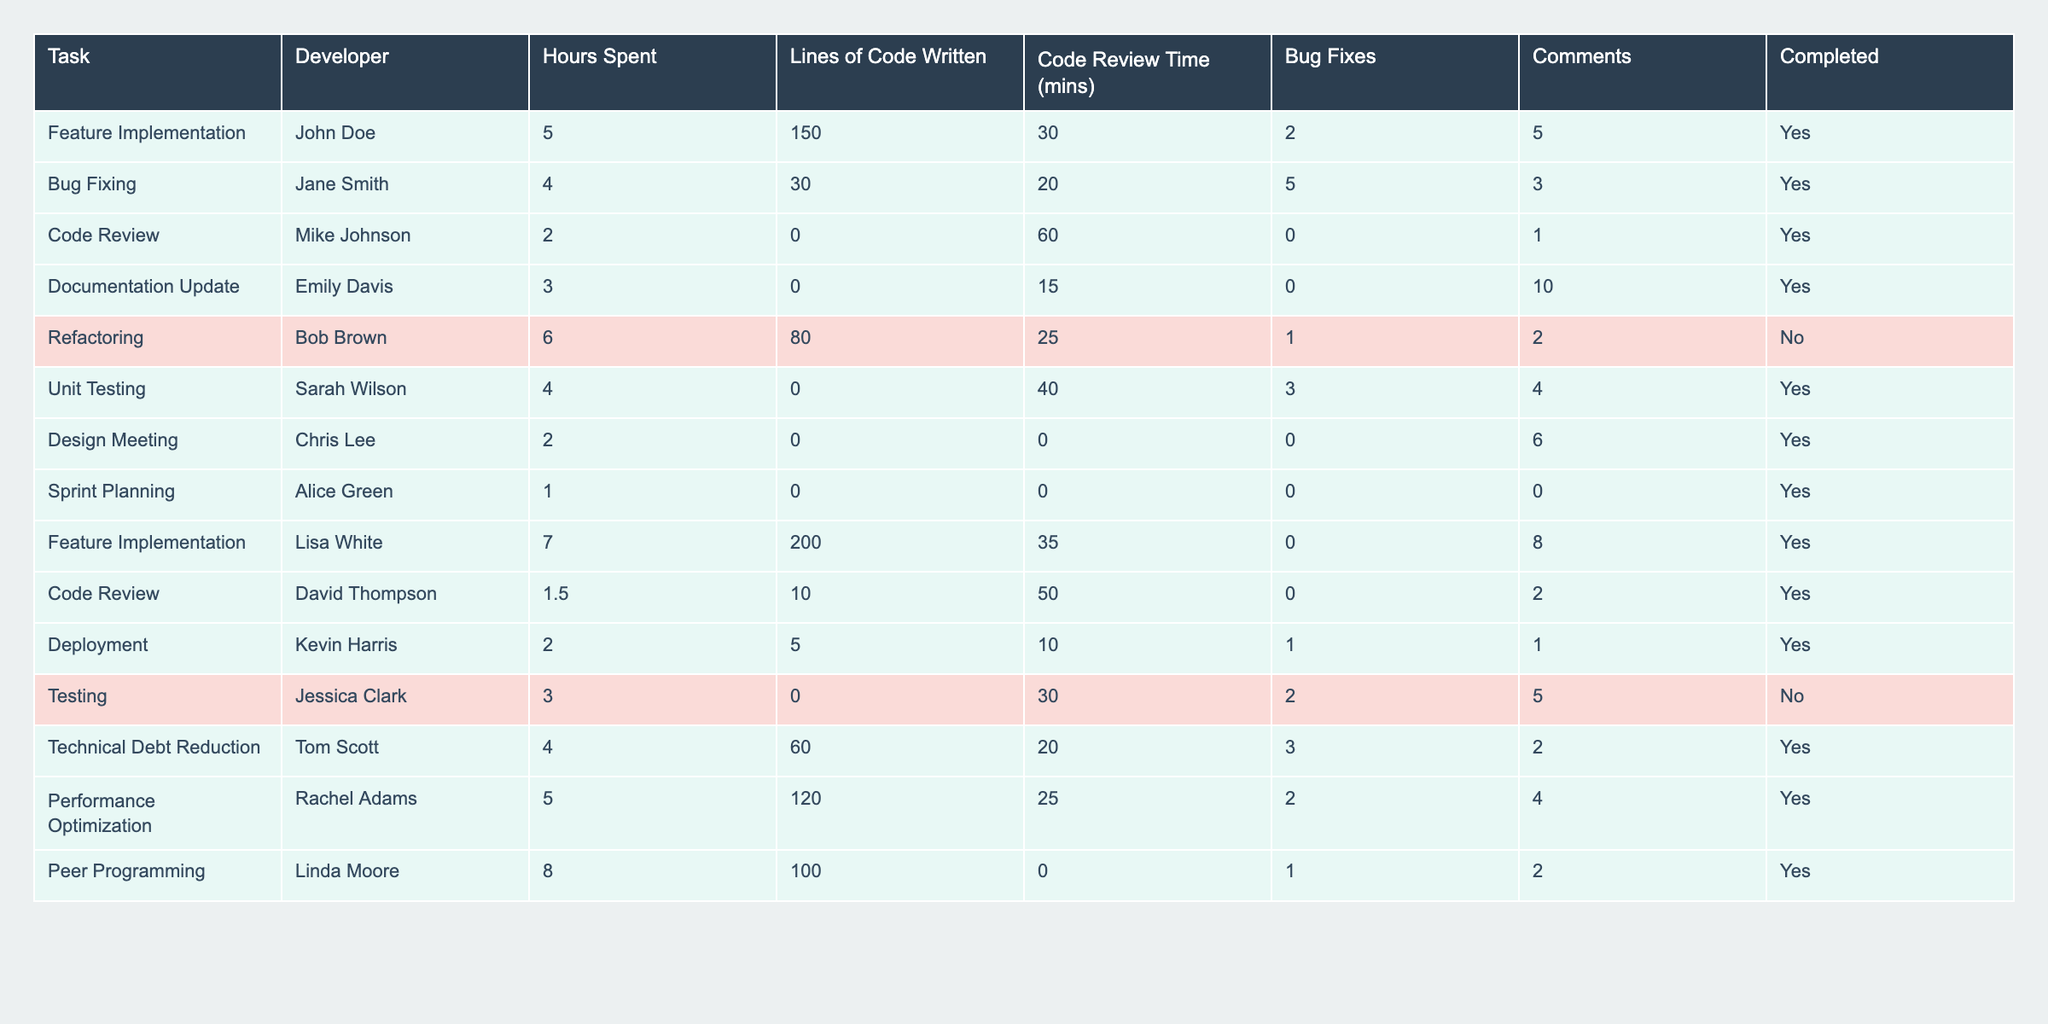What is the total number of hours spent on all tasks? To find the total hours spent, add the "Hours Spent" values from each task: 5 + 4 + 2 + 3 + 6 + 4 + 2 + 1 + 7 + 1.5 + 2 + 3 + 4 + 5 + 8 = 56.5 hours.
Answer: 56.5 How many tasks were completed? Count the number of rows where "Completed" is marked as "Yes." There are 11 tasks completed in total.
Answer: 11 What is the average lines of code written per task? Sum the total lines of code written: 150 + 30 + 0 + 0 + 80 + 0 + 0 + 0 + 200 + 10 + 5 + 0 + 60 + 120 + 100 = 695. Then, divide by the total number of tasks (15): 695 / 15 = 46.33.
Answer: 46.33 Who spent the most hours on a single task? Look at the "Hours Spent" column to find the maximum value, which is 8 hours by Linda Moore for Peer Programming.
Answer: Linda Moore Is the task "Feature Implementation" completed? Check the "Completed" column for the "Feature Implementation" tasks, both are marked as "Yes."
Answer: Yes How many more bug fixes did Jane Smith complete compared to Kevin Harris? Jane Smith completed 5 bug fixes while Kevin Harris completed 1. The difference is 5 - 1 = 4.
Answer: 4 What is the total code review time for all tasks? Add the "Code Review Time (mins)" for all tasks: 30 + 20 + 60 + 15 + 25 + 40 + 0 + 0 + 35 + 50 + 10 + 30 + 20 + 25 + 0 =  315 minutes.
Answer: 315 Which developer worked on tasks that were not completed? Review the "Completed" column for tasks marked as "No." Referring to the table, Bob Brown and Jessica Clark worked on tasks that were not completed.
Answer: Bob Brown and Jessica Clark What percentage of tasks were completed successfully? There are 15 total tasks, and 11 were completed. The percentage is (11/15) * 100 ≈ 73.33%.
Answer: 73.33% What was the average number of comments made per task? Total comments: 5 + 3 + 1 + 10 + 2 + 4 + 6 + 0 + 8 + 2 + 1 + 5 + 2 + 4 + 2 = 58. Divide by the total number of tasks (15): 58 / 15 ≈ 3.87.
Answer: 3.87 